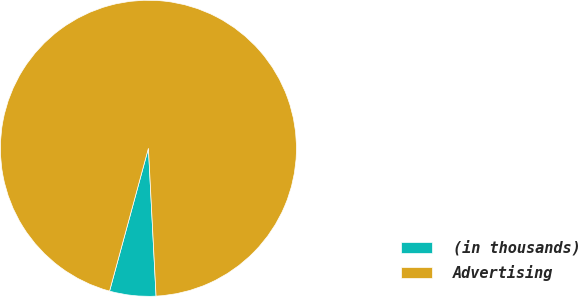Convert chart to OTSL. <chart><loc_0><loc_0><loc_500><loc_500><pie_chart><fcel>(in thousands)<fcel>Advertising<nl><fcel>5.05%<fcel>94.95%<nl></chart> 